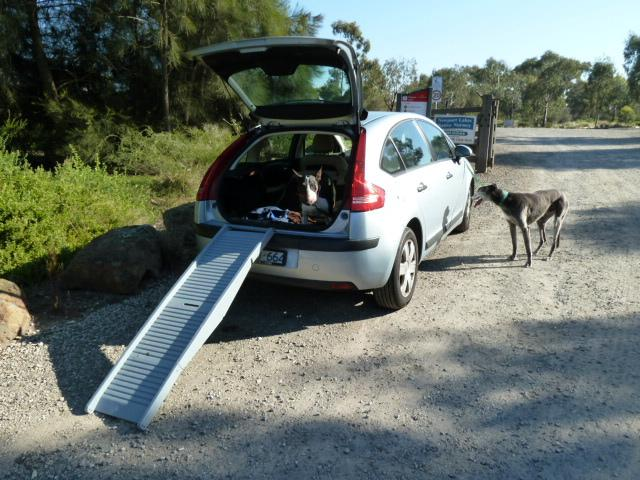What uses the ramp on the back of the car? Please explain your reasoning. dogs. This is used when they get old and can't jump up anymore 